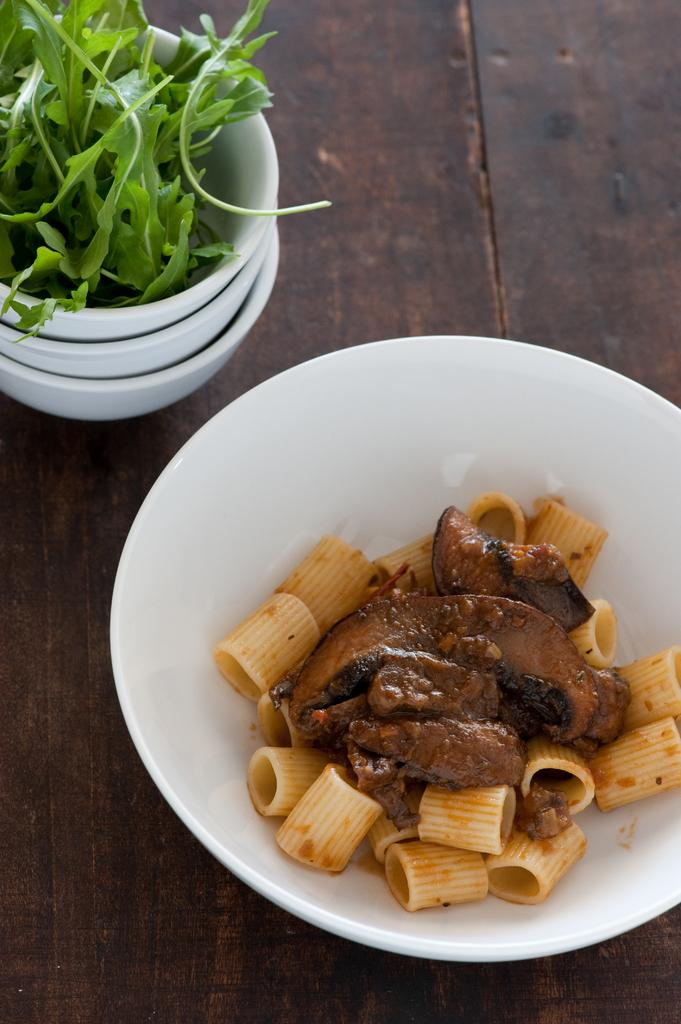What type of food is in the bowl in the image? There are leafy vegetables in the bowl in the image. How many bowls are visible in the image? There are bowls on a wooden object, but the exact number is not specified. What material is the object holding the bowls made of? The object holding the bowls is made of wood. What is the plot of the story depicted in the image? There is no story or plot depicted in the image; it simply shows bowls with leafy vegetables on a wooden object. 